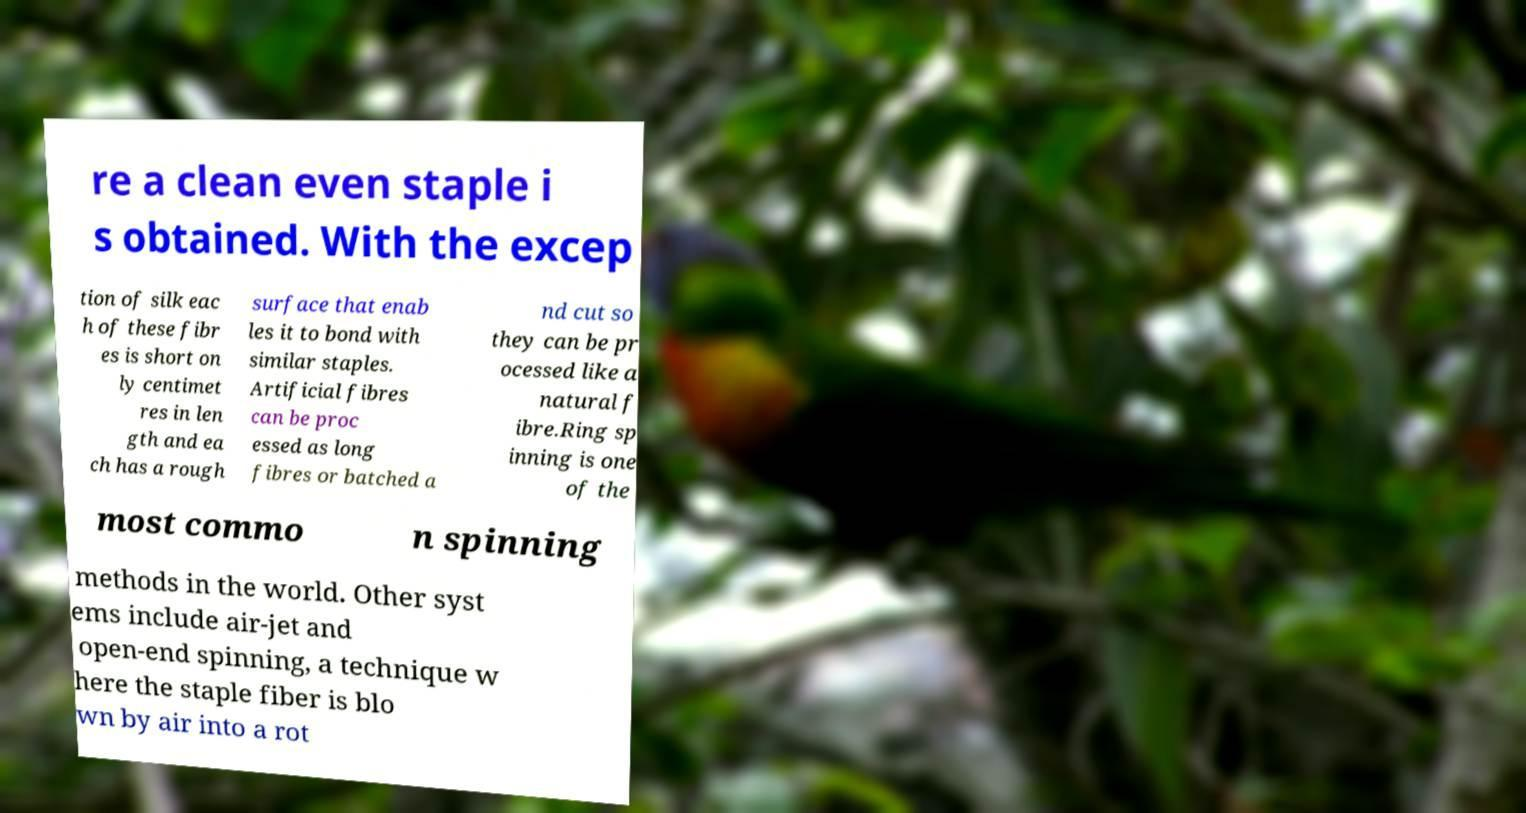Please read and relay the text visible in this image. What does it say? re a clean even staple i s obtained. With the excep tion of silk eac h of these fibr es is short on ly centimet res in len gth and ea ch has a rough surface that enab les it to bond with similar staples. Artificial fibres can be proc essed as long fibres or batched a nd cut so they can be pr ocessed like a natural f ibre.Ring sp inning is one of the most commo n spinning methods in the world. Other syst ems include air-jet and open-end spinning, a technique w here the staple fiber is blo wn by air into a rot 